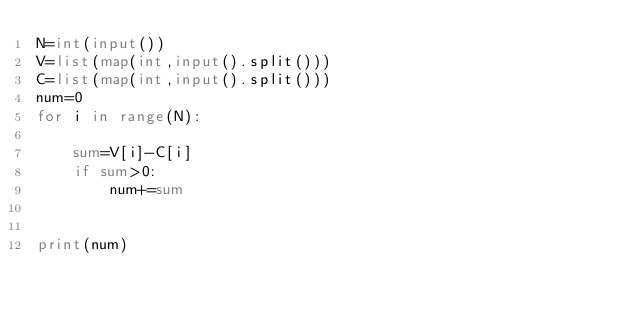Convert code to text. <code><loc_0><loc_0><loc_500><loc_500><_Python_>N=int(input())
V=list(map(int,input().split()))
C=list(map(int,input().split()))
num=0
for i in range(N):

    sum=V[i]-C[i]
    if sum>0:
        num+=sum


print(num)
</code> 